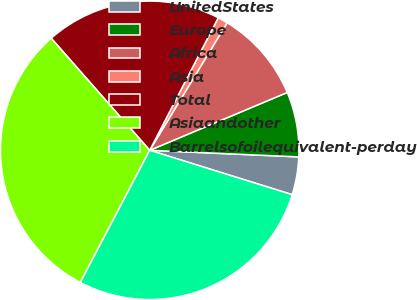Convert chart. <chart><loc_0><loc_0><loc_500><loc_500><pie_chart><fcel>UnitedStates<fcel>Europe<fcel>Africa<fcel>Asia<fcel>Total<fcel>Asiaandother<fcel>Barrelsofoilequivalent-perday<nl><fcel>4.1%<fcel>7.04%<fcel>9.98%<fcel>1.09%<fcel>19.07%<fcel>30.83%<fcel>27.89%<nl></chart> 